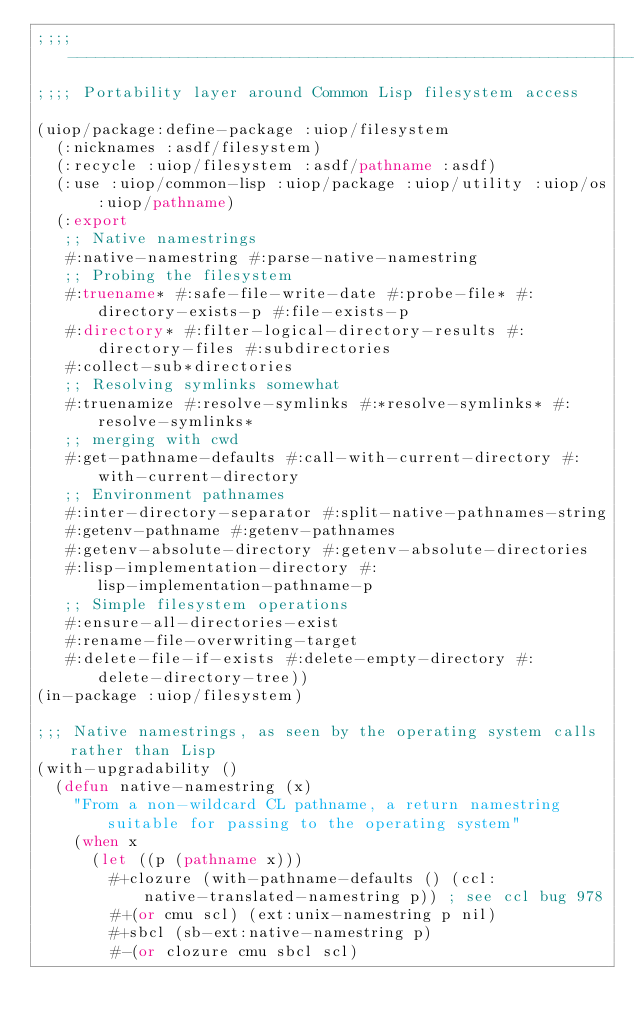Convert code to text. <code><loc_0><loc_0><loc_500><loc_500><_Lisp_>;;;; -------------------------------------------------------------------------
;;;; Portability layer around Common Lisp filesystem access

(uiop/package:define-package :uiop/filesystem
  (:nicknames :asdf/filesystem)
  (:recycle :uiop/filesystem :asdf/pathname :asdf)
  (:use :uiop/common-lisp :uiop/package :uiop/utility :uiop/os :uiop/pathname)
  (:export
   ;; Native namestrings
   #:native-namestring #:parse-native-namestring
   ;; Probing the filesystem
   #:truename* #:safe-file-write-date #:probe-file* #:directory-exists-p #:file-exists-p
   #:directory* #:filter-logical-directory-results #:directory-files #:subdirectories
   #:collect-sub*directories
   ;; Resolving symlinks somewhat
   #:truenamize #:resolve-symlinks #:*resolve-symlinks* #:resolve-symlinks*
   ;; merging with cwd
   #:get-pathname-defaults #:call-with-current-directory #:with-current-directory
   ;; Environment pathnames
   #:inter-directory-separator #:split-native-pathnames-string
   #:getenv-pathname #:getenv-pathnames
   #:getenv-absolute-directory #:getenv-absolute-directories
   #:lisp-implementation-directory #:lisp-implementation-pathname-p
   ;; Simple filesystem operations
   #:ensure-all-directories-exist
   #:rename-file-overwriting-target
   #:delete-file-if-exists #:delete-empty-directory #:delete-directory-tree))
(in-package :uiop/filesystem)

;;; Native namestrings, as seen by the operating system calls rather than Lisp
(with-upgradability ()
  (defun native-namestring (x)
    "From a non-wildcard CL pathname, a return namestring suitable for passing to the operating system"
    (when x
      (let ((p (pathname x)))
        #+clozure (with-pathname-defaults () (ccl:native-translated-namestring p)) ; see ccl bug 978
        #+(or cmu scl) (ext:unix-namestring p nil)
        #+sbcl (sb-ext:native-namestring p)
        #-(or clozure cmu sbcl scl)</code> 